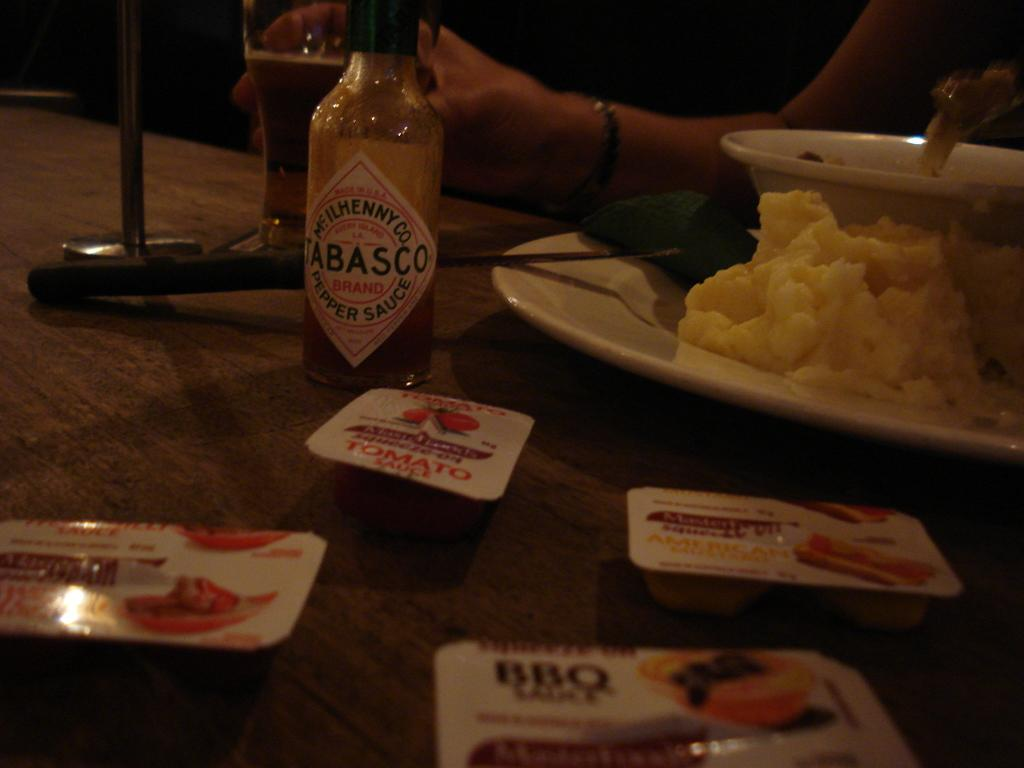<image>
Write a terse but informative summary of the picture. Food on a table next to some sauce including TOMATO sauce. 